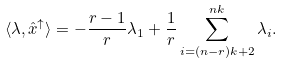Convert formula to latex. <formula><loc_0><loc_0><loc_500><loc_500>\langle \lambda , \hat { x } ^ { \uparrow } \rangle = - \frac { r - 1 } { r } \lambda _ { 1 } + \frac { 1 } { r } \sum _ { i = ( n - r ) k + 2 } ^ { n k } \lambda _ { i } .</formula> 